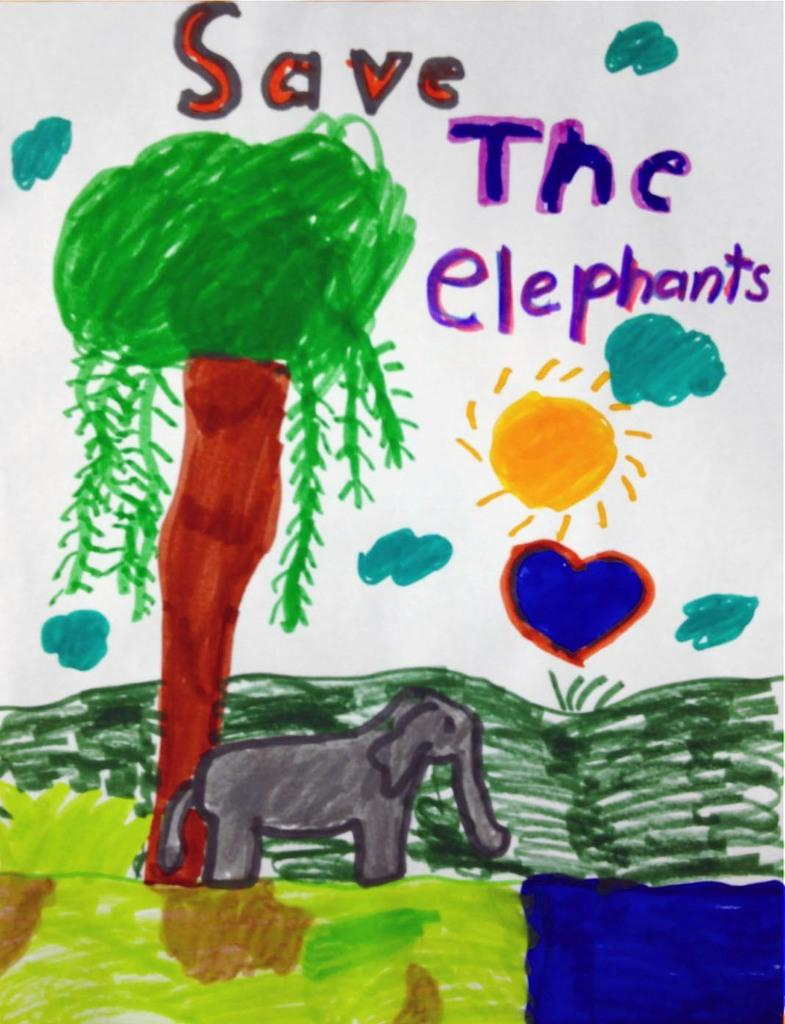What medium is used for the artwork in the image? The image is a painting on paper. What natural element is depicted in the painting? There is a tree in the painting. What animal is featured in the painting? There is an elephant in the painting. Are there any words or letters in the painting? Yes, there is text written in the painting. How does the organization of the sand contribute to the painting's composition? There is no sand present in the painting, so its organization cannot contribute to the composition. 